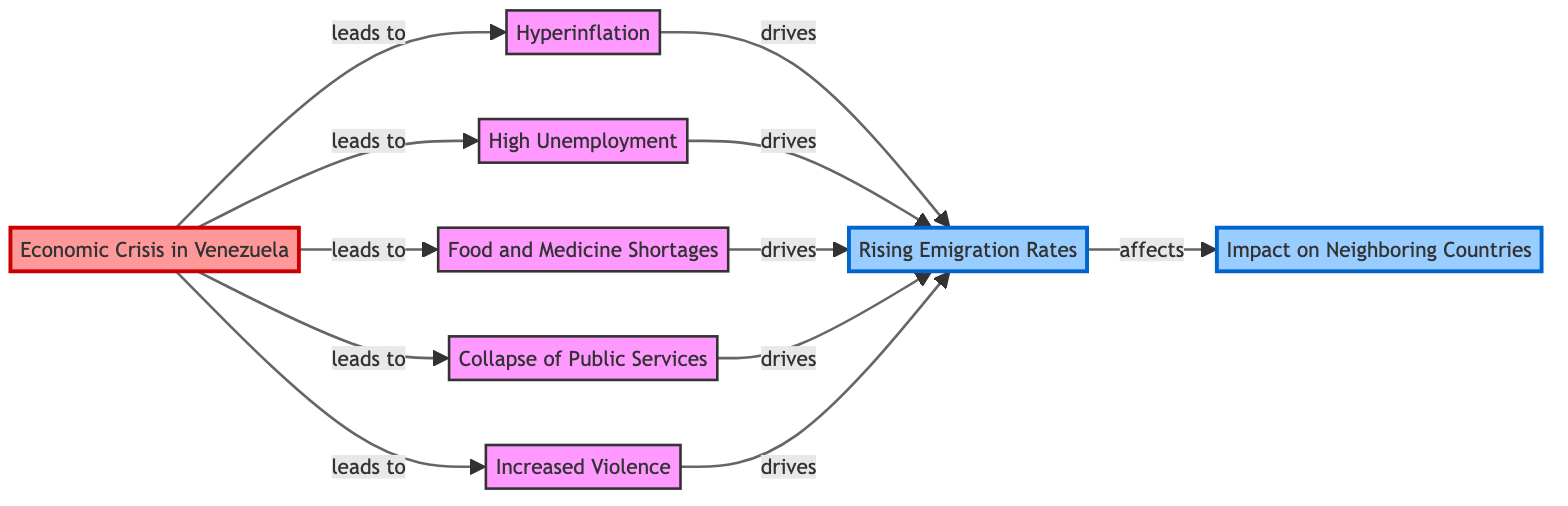What is the main cause of rising emigration rates in Venezuela? The main cause of rising emigration rates in Venezuela is the economic crisis. The diagram indicates that the "Economic Crisis in Venezuela" is at the beginning and leads to various issues, which ultimately drive emigration.
Answer: Economic Crisis in Venezuela How many direct consequences does the economic crisis have on emigration? The economic crisis has five direct consequences that drive emigration: hyperinflation, high unemployment, food and medicine shortages, collapse of public services, and increased violence. These are all depicted as edges leading to the "Rising Emigration Rates" node.
Answer: Five Which factor directly leads to hyperinflation? The diagram shows that hyperinflation is a direct consequence of the economic crisis. Therefore, the factor that directly leads to hyperinflation is the economic crisis itself.
Answer: Economic Crisis in Venezuela What node affects the neighboring countries? The rising emigration rates affect the neighboring countries, as indicated by the edge that goes from the "Rising Emigration Rates" node to "Impact on Neighboring Countries."
Answer: Rising Emigration Rates What do high unemployment and violence both drive? High unemployment and violence both drive rising emigration rates, as represented by the edges leading from these nodes to the "Rising Emigration Rates" node.
Answer: Rising Emigration Rates How many nodes are there representing effects on the public? There are five nodes representing effects that directly link to the public's quality of life, which are hyperinflation, high unemployment, food shortages, public services collapse, and increased violence. Each of these factors are shown to stem from the economic crisis.
Answer: Five 